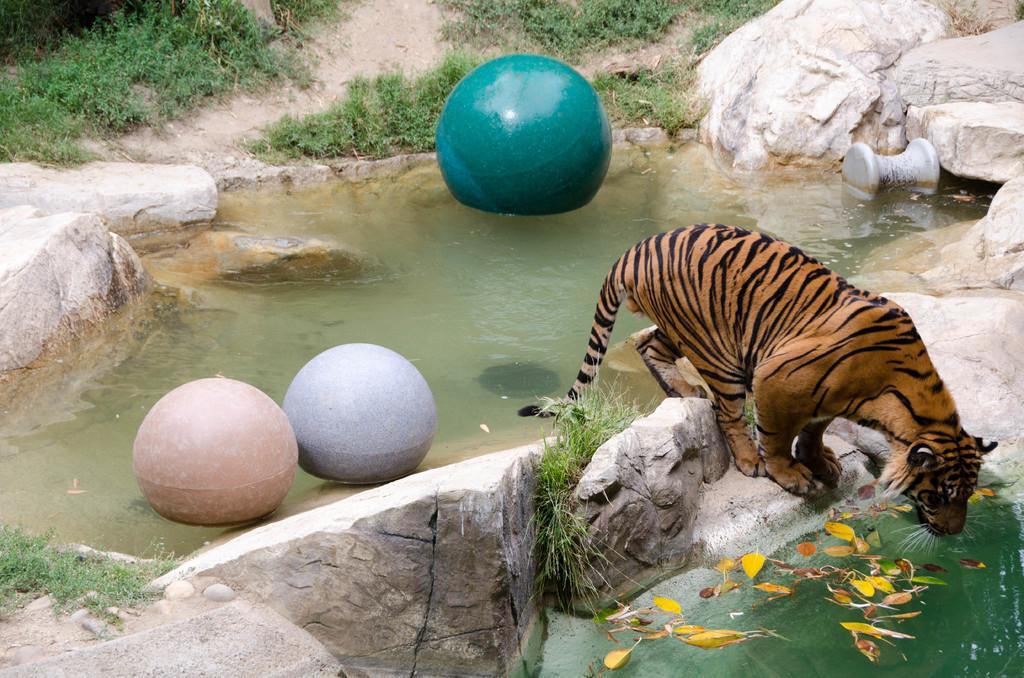Describe this image in one or two sentences. In the picture we can see tiger which is standing on the stone surface, there is water, there are some balloons and in the background of the picture there is grass. 